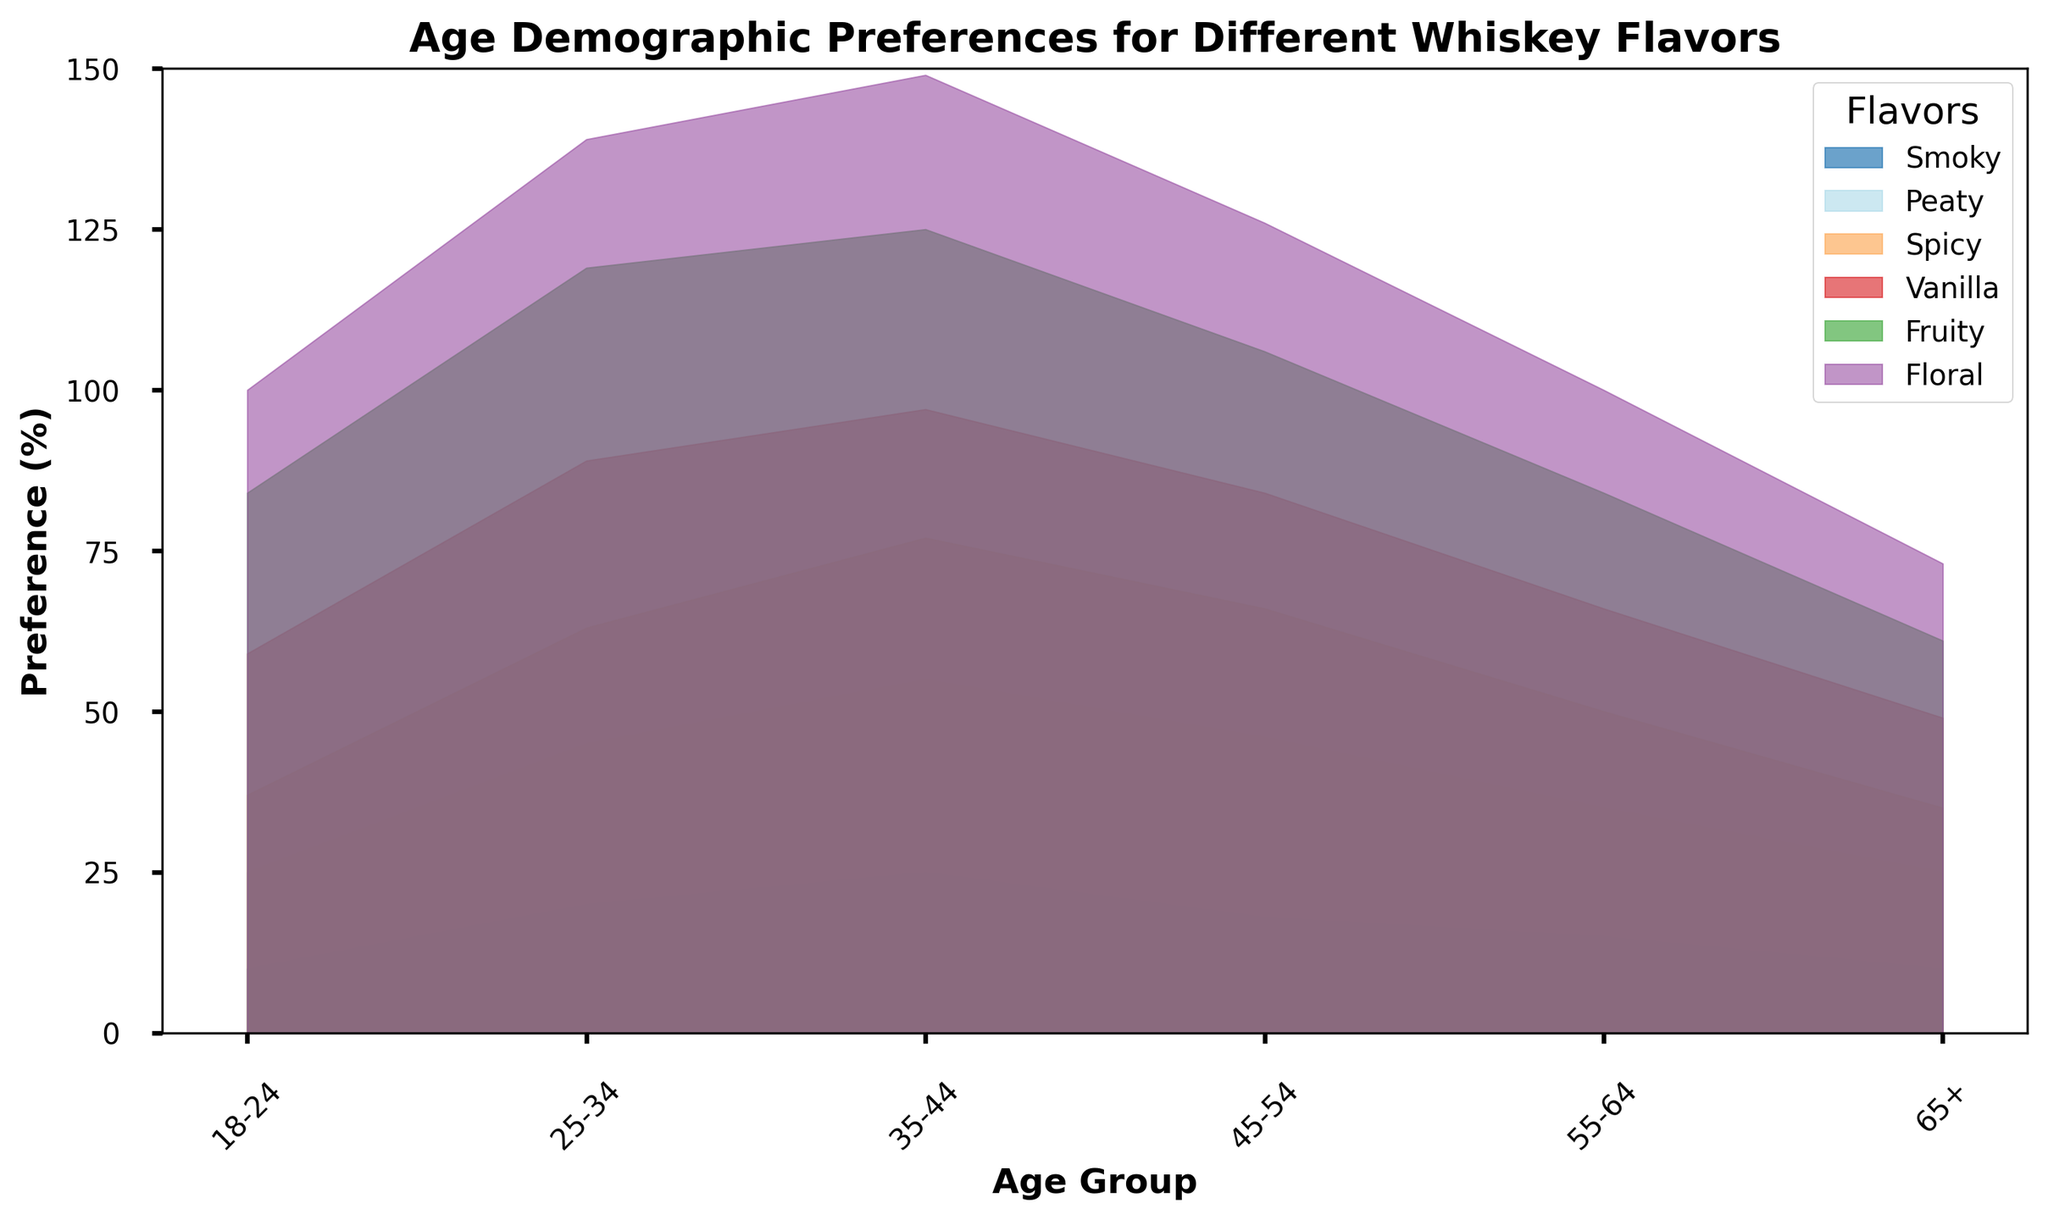What's the most preferred whiskey flavor by the age group 25-34? In the age group 25-34, we look at the highest value among the flavors. For Smoky it is 20, Peaty is 25, Spicy is 18, Vanilla is 26, Fruity is 30, and Floral is 20. The highest value is 30 for Fruity flavor.
Answer: Fruity How does the preference for Spicy flavor change as age increases from 18-24 to 35-44? In the age group 18-24, the preference for Spicy flavor is 12. For age group 25-34, it is 18, and for the age group 35-44, it is 22. The preference increases from 12 to 18 to 22.
Answer: It increases Which age group has the lowest preference for Floral flavor? We compare the Floral flavor values for all age groups. The values are 16 for 18-24, 20 for 25-34, 24 for 35-44, 20 for 45-54, 16 for 55-64, and 12 for 65+. The lowest value is 12 for the 65+ age group.
Answer: 65+ By how much does the preference for Vanilla flavor decrease from the age group 25-34 to 65+? The preference for Vanilla flavor in the age group 25-34 is 26. In the age group 65+, it is 14. The decrease is 26 - 14 = 12.
Answer: 12 What is the combined preference percentage for Smoky and Peaty flavors in the age group 35-44? The preference for Smoky flavor in the age group 35-44 is 25 and for Peaty flavor, it is 30. The combined preference is 25 + 30 = 55.
Answer: 55 Which flavor has a preference that does not decrease consistently with age? We look for inconsistencies in the patterns of preferences across age groups. Most show a consistent decrease. However, Spicy flavor shows a non-linear pattern (12 → 18 → 22 → 20 → 15 → 10).
Answer: Spicy In which age group is the combined preference for Vanilla and Fruity flavors the highest? We calculate the combined preferences for each age group. The values are 47, 56, 48, 40, 34, and 26 for age groups 18-24, 25-34, 35-44, 45-54, 55-64, and 65+ respectively. The highest combined preference is 56 for the age group 25-34.
Answer: 25-34 